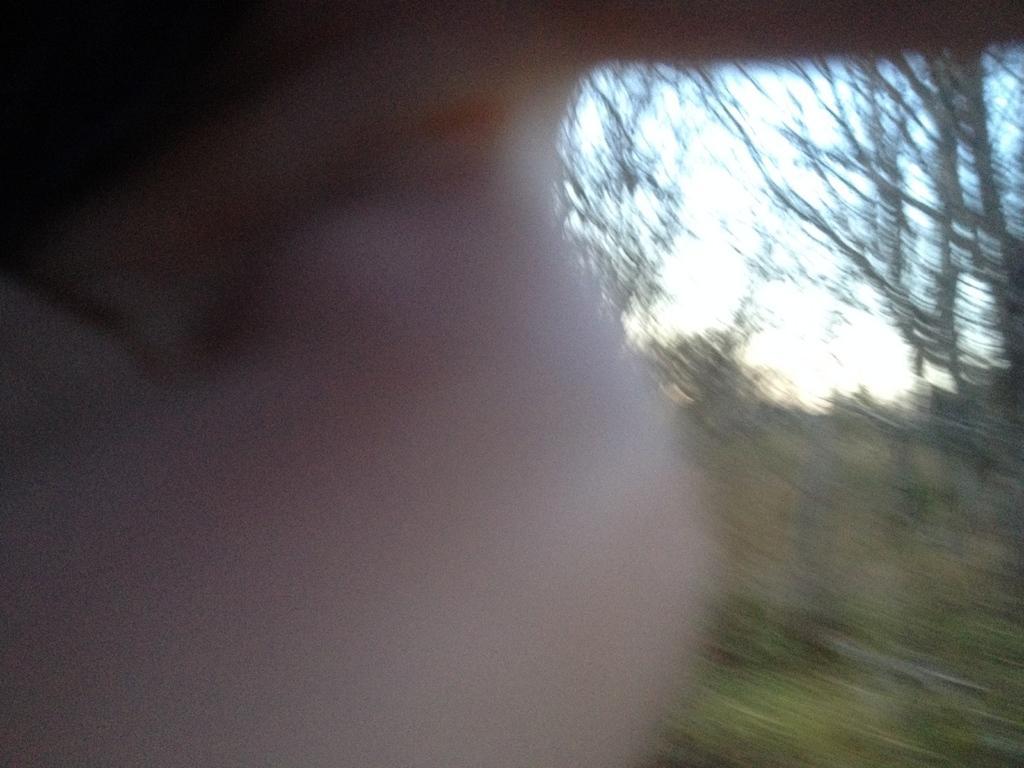Describe this image in one or two sentences. In this picture it is looking like a person hand and behind the person hand, there are trees and a sky. 